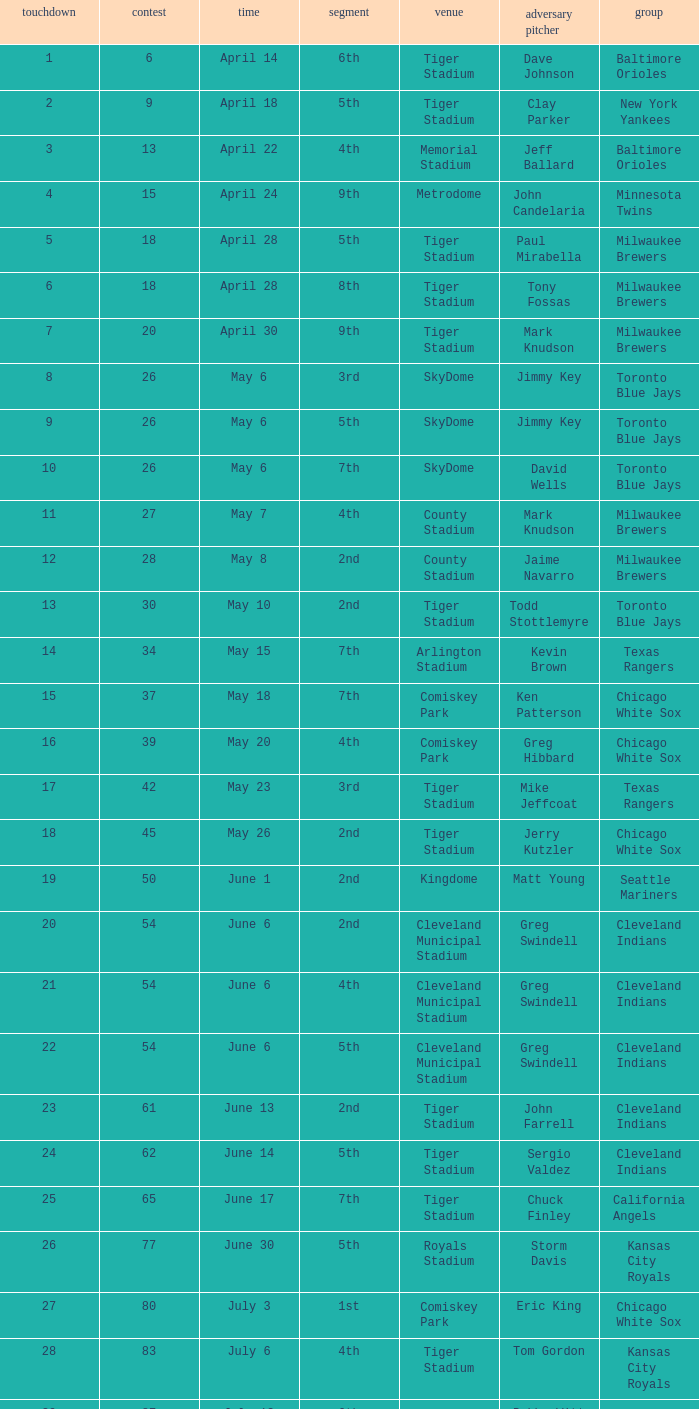What date was the game at Comiskey Park and had a 4th Inning? May 20. 